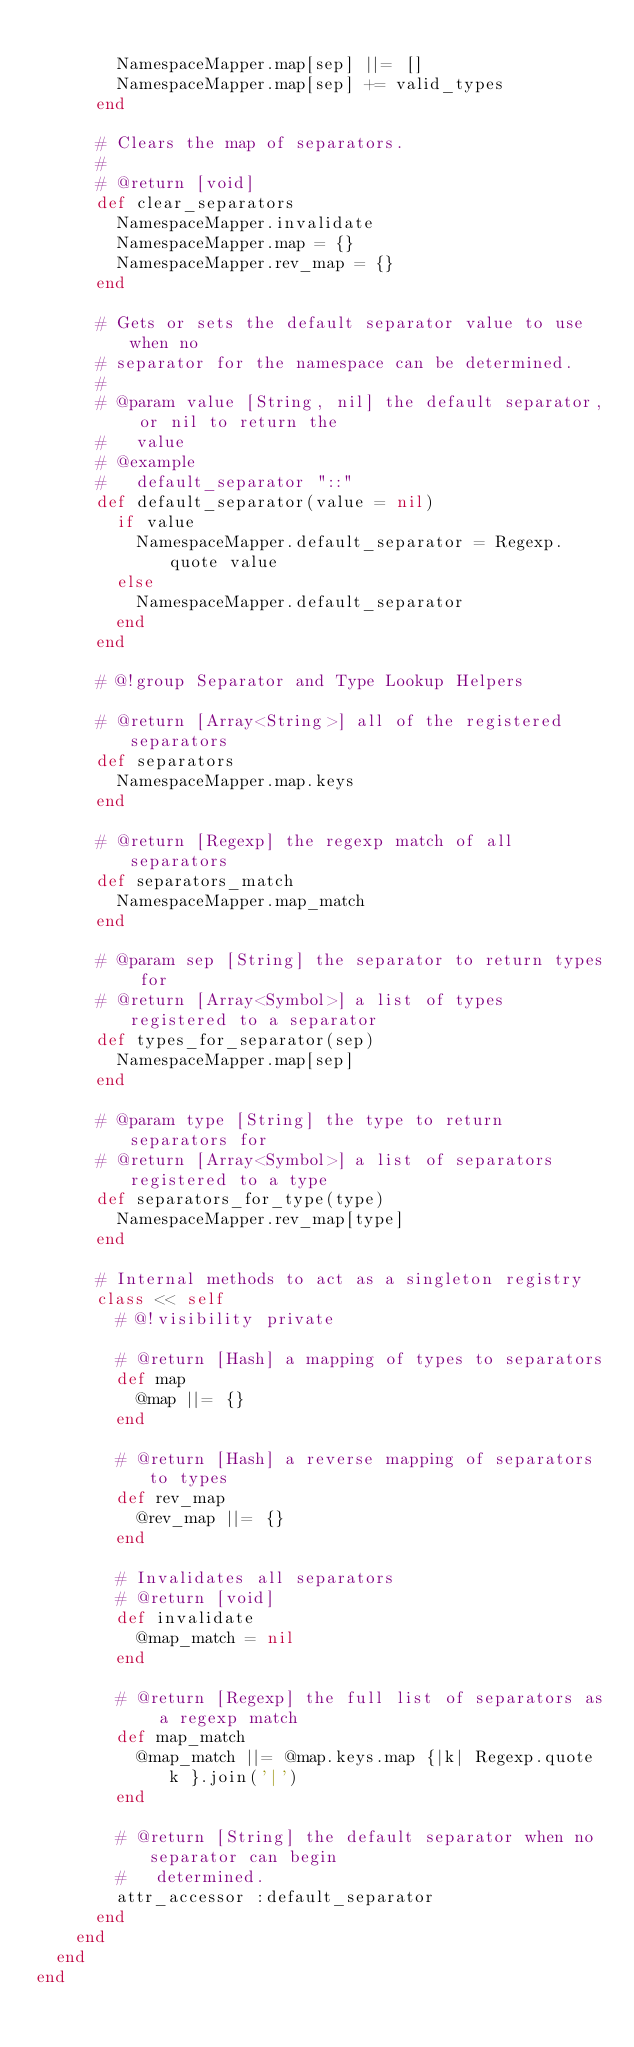Convert code to text. <code><loc_0><loc_0><loc_500><loc_500><_Ruby_>
        NamespaceMapper.map[sep] ||= []
        NamespaceMapper.map[sep] += valid_types
      end

      # Clears the map of separators.
      #
      # @return [void]
      def clear_separators
        NamespaceMapper.invalidate
        NamespaceMapper.map = {}
        NamespaceMapper.rev_map = {}
      end

      # Gets or sets the default separator value to use when no
      # separator for the namespace can be determined.
      #
      # @param value [String, nil] the default separator, or nil to return the
      #   value
      # @example
      #   default_separator "::"
      def default_separator(value = nil)
        if value
          NamespaceMapper.default_separator = Regexp.quote value
        else
          NamespaceMapper.default_separator
        end
      end

      # @!group Separator and Type Lookup Helpers

      # @return [Array<String>] all of the registered separators
      def separators
        NamespaceMapper.map.keys
      end

      # @return [Regexp] the regexp match of all separators
      def separators_match
        NamespaceMapper.map_match
      end

      # @param sep [String] the separator to return types for
      # @return [Array<Symbol>] a list of types registered to a separator
      def types_for_separator(sep)
        NamespaceMapper.map[sep]
      end

      # @param type [String] the type to return separators for
      # @return [Array<Symbol>] a list of separators registered to a type
      def separators_for_type(type)
        NamespaceMapper.rev_map[type]
      end

      # Internal methods to act as a singleton registry
      class << self
        # @!visibility private

        # @return [Hash] a mapping of types to separators
        def map
          @map ||= {}
        end

        # @return [Hash] a reverse mapping of separators to types
        def rev_map
          @rev_map ||= {}
        end

        # Invalidates all separators
        # @return [void]
        def invalidate
          @map_match = nil
        end

        # @return [Regexp] the full list of separators as a regexp match
        def map_match
          @map_match ||= @map.keys.map {|k| Regexp.quote k }.join('|')
        end

        # @return [String] the default separator when no separator can begin
        #   determined.
        attr_accessor :default_separator
      end
    end
  end
end
</code> 